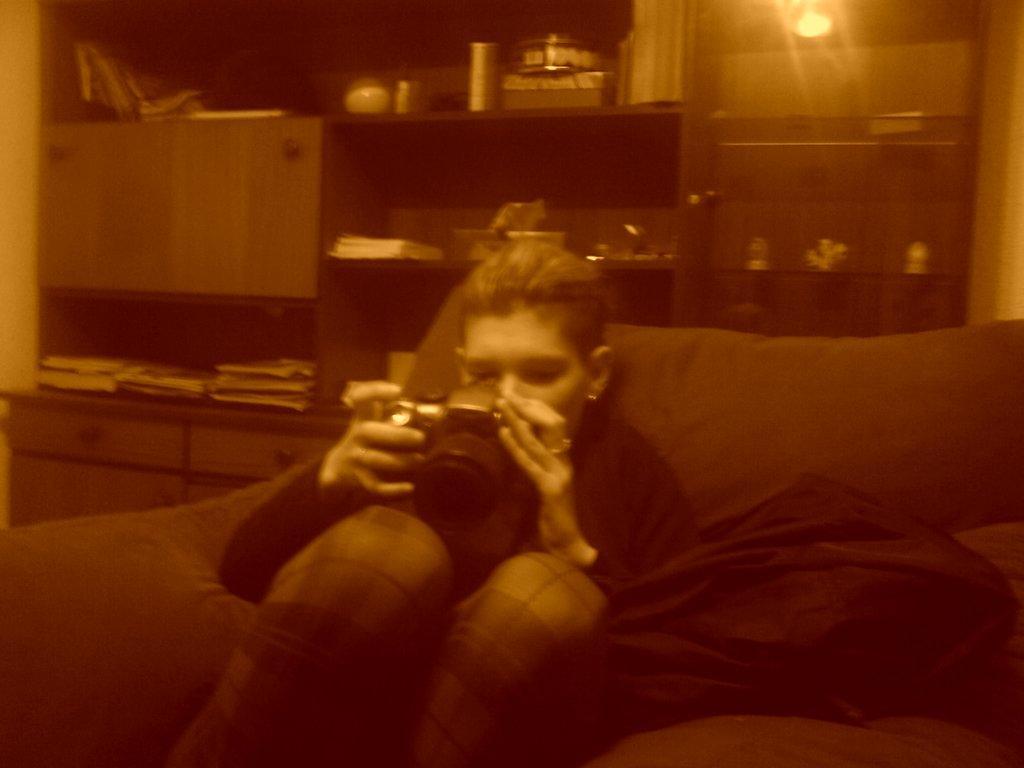Can you describe this image briefly? In this image we can see a person sitting on the couch. There is an object on the couch. There are many objects placed on the shelves. There are wooden cabinets in the image. There is a reflection of lamp on the glass in the image. 